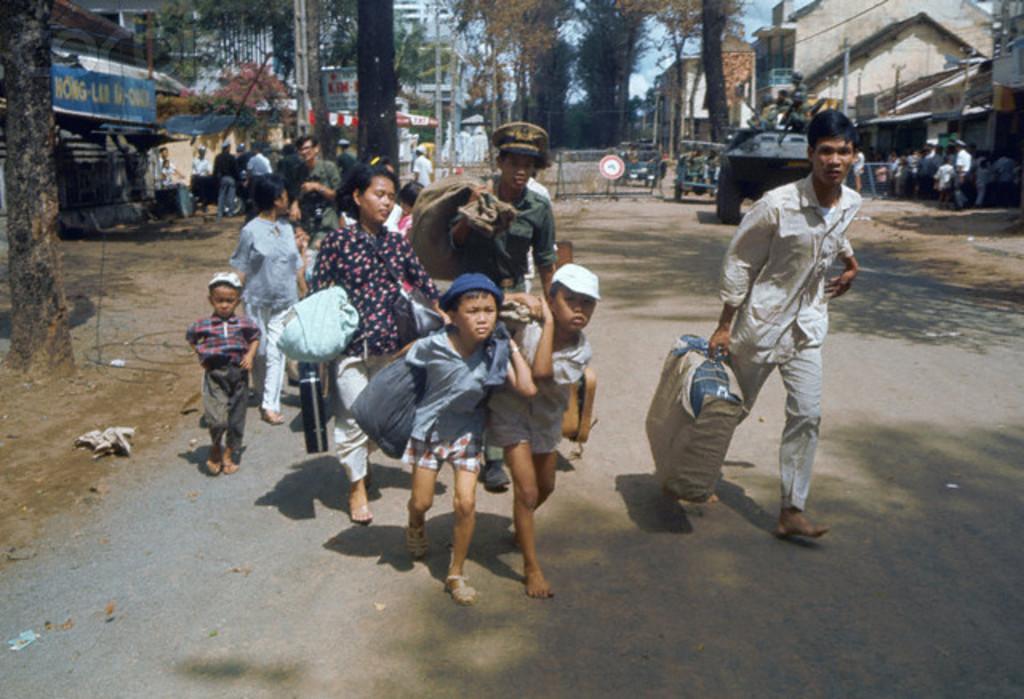Can you describe this image briefly? Here in this picture we can see a group of children and person walking on the road carrying bags on them over there and we can see some of them are wearing caps on them and behind them we can see trees present here and there, we can see shops and house over there and on the road we can see tanks and jeeps present and we can also see some people sitting here and there on the stalls over there. 